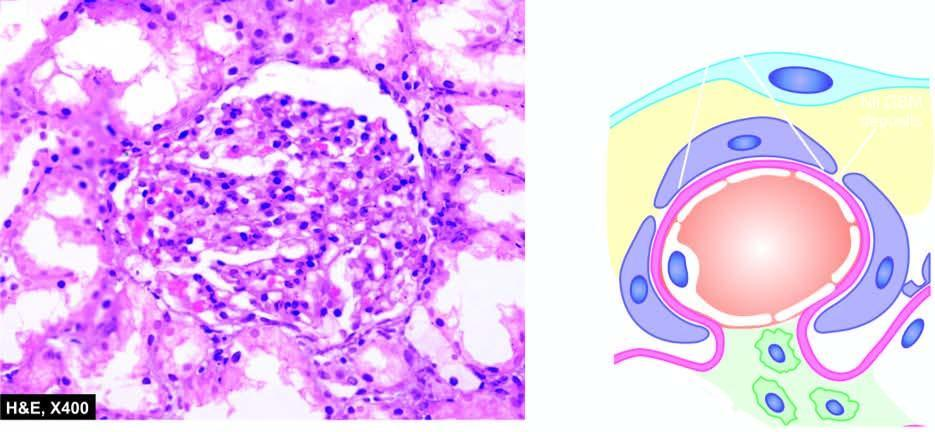do large cystic spaces lined by the flattened endothelial cells and containing lymph show cytoplasmic?
Answer the question using a single word or phrase. No 